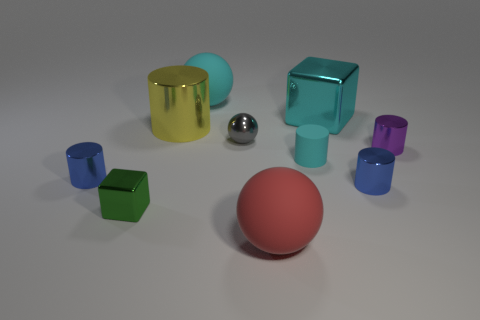There is a red ball; is its size the same as the green thing that is in front of the big cylinder?
Offer a terse response. No. There is a cyan matte thing to the right of the big rubber ball in front of the blue metallic cylinder that is left of the tiny matte cylinder; what is its size?
Offer a very short reply. Small. Are any red things visible?
Your answer should be very brief. Yes. There is a ball that is the same color as the big metal block; what is its material?
Your answer should be compact. Rubber. What number of other cubes have the same color as the big cube?
Provide a short and direct response. 0. How many objects are either small metallic cylinders to the right of the red thing or objects behind the small purple metal object?
Provide a short and direct response. 6. How many metal objects are left of the rubber object that is in front of the tiny cyan rubber cylinder?
Offer a terse response. 4. There is another block that is made of the same material as the large block; what is its color?
Provide a succinct answer. Green. Is there a cyan block of the same size as the red matte thing?
Your response must be concise. Yes. What shape is the gray object that is the same size as the purple cylinder?
Your answer should be very brief. Sphere. 